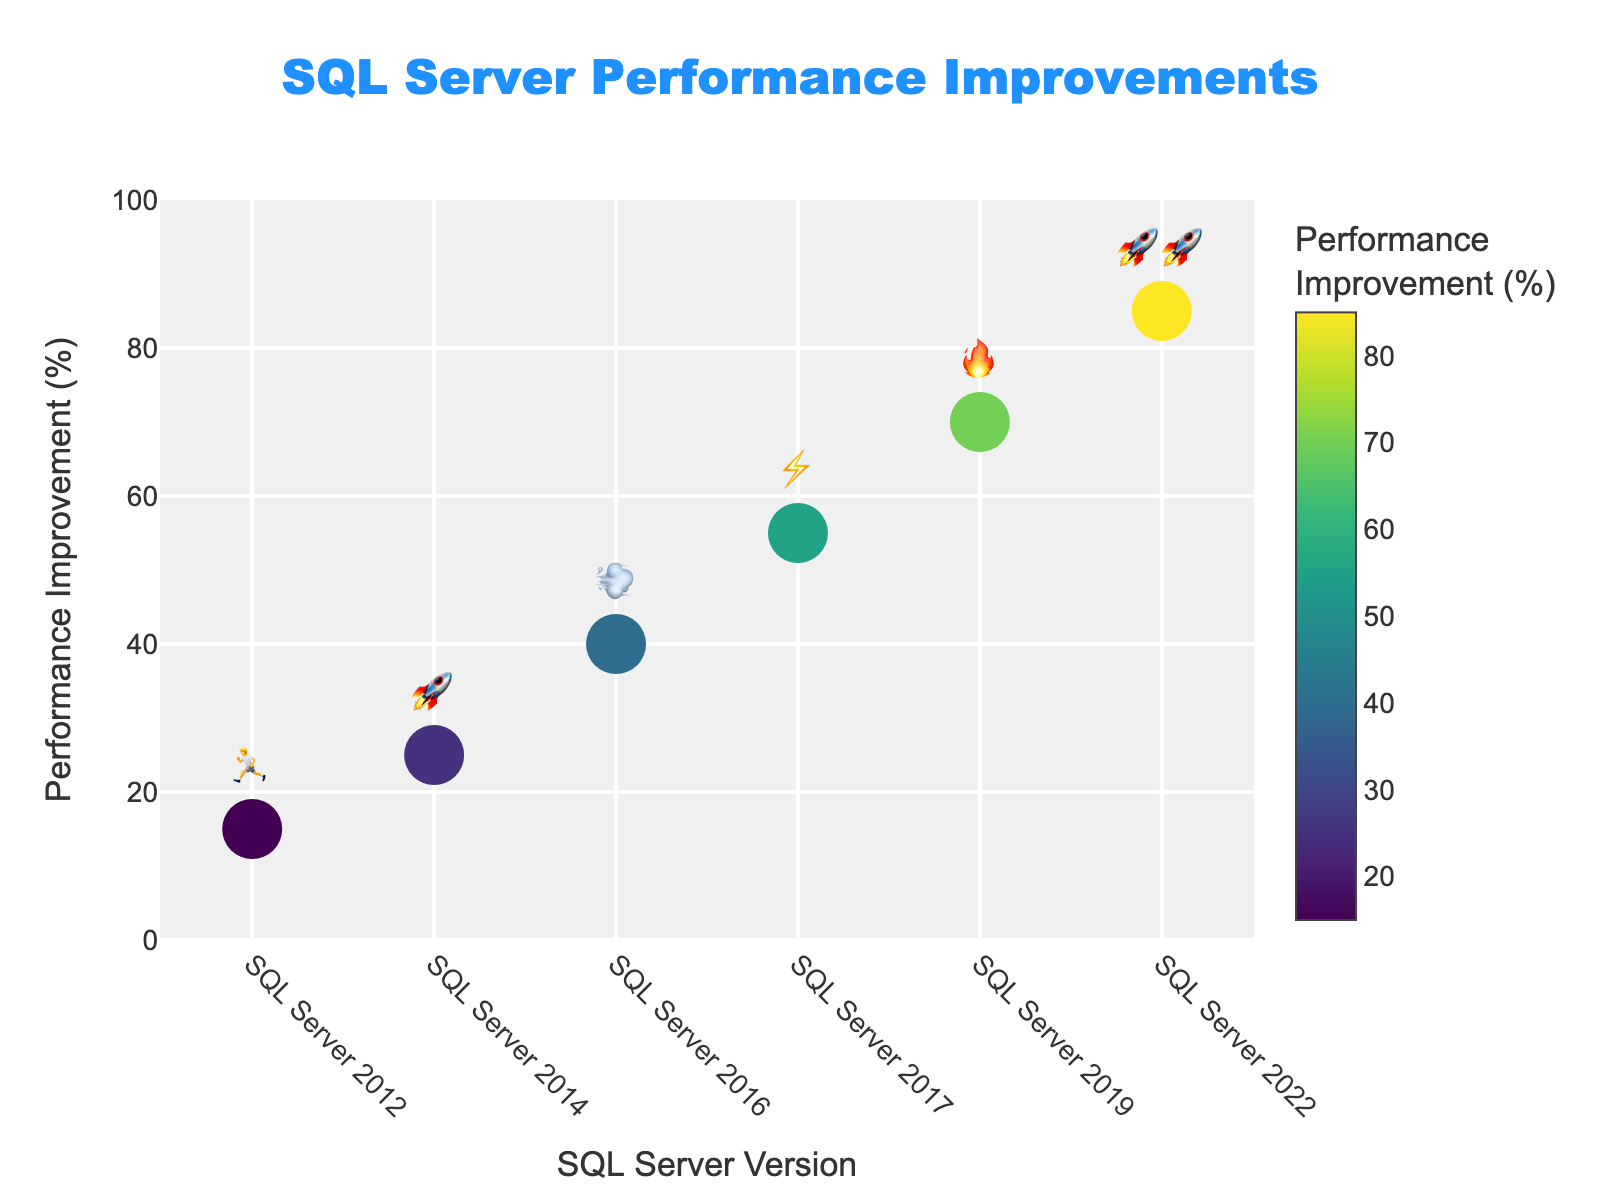What is the title of the figure? The title of a figure is usually located at the top of the chart. In this case, it is clearly stated near the top middle.
Answer: SQL Server Performance Improvements How many versions of SQL Server are presented in the figure? By counting the unique versions listed along the x-axis, we can determine the number of SQL Server versions shown.
Answer: 6 Which SQL Server version shows the highest performance improvement? To find the version with the highest performance improvement, we look for the point on the y-axis with the greatest value.
Answer: SQL Server 2022 What is the performance improvement percentage for SQL Server 2016? Locate the point for SQL Server 2016 along the x-axis and check its corresponding value on the y-axis.
Answer: 40% How much did the performance improve from SQL Server 2012 to SQL Server 2019? Subtract the performance improvement percentage of SQL Server 2012 from that of SQL Server 2019: 70% - 15% = 55%
Answer: 55% Which two versions have "rocket" emojis, and what is their combined performance improvement percentage? Identify the versions with the "rocket" emojis (🚀) and sum their performance improvements: SQL Server 2014 (25%) and SQL Server 2022 (85%). Combined improvement = 25% + 85% = 110%
Answer: SQL Server 2014 and SQL Server 2022; 110% Is the performance improvement for SQL Server 2017 greater or less than that for SQL Server 2016? Compare the performance improvement percentages for SQL Server 2017 (55%) and SQL Server 2016 (40%).
Answer: Greater Which SQL Server version has a performance improvement represented by a "fire" emoji? Look for the version on the x-axis whose marker is accompanied by a "fire" emoji (🔥).
Answer: SQL Server 2019 What is the average performance improvement across all SQL Server versions shown in this figure? Add the performance improvements of all versions and divide by the number of versions: (15% + 25% + 40% + 55% + 70% + 85%)/6 = 48.33%
Answer: 48.33% 